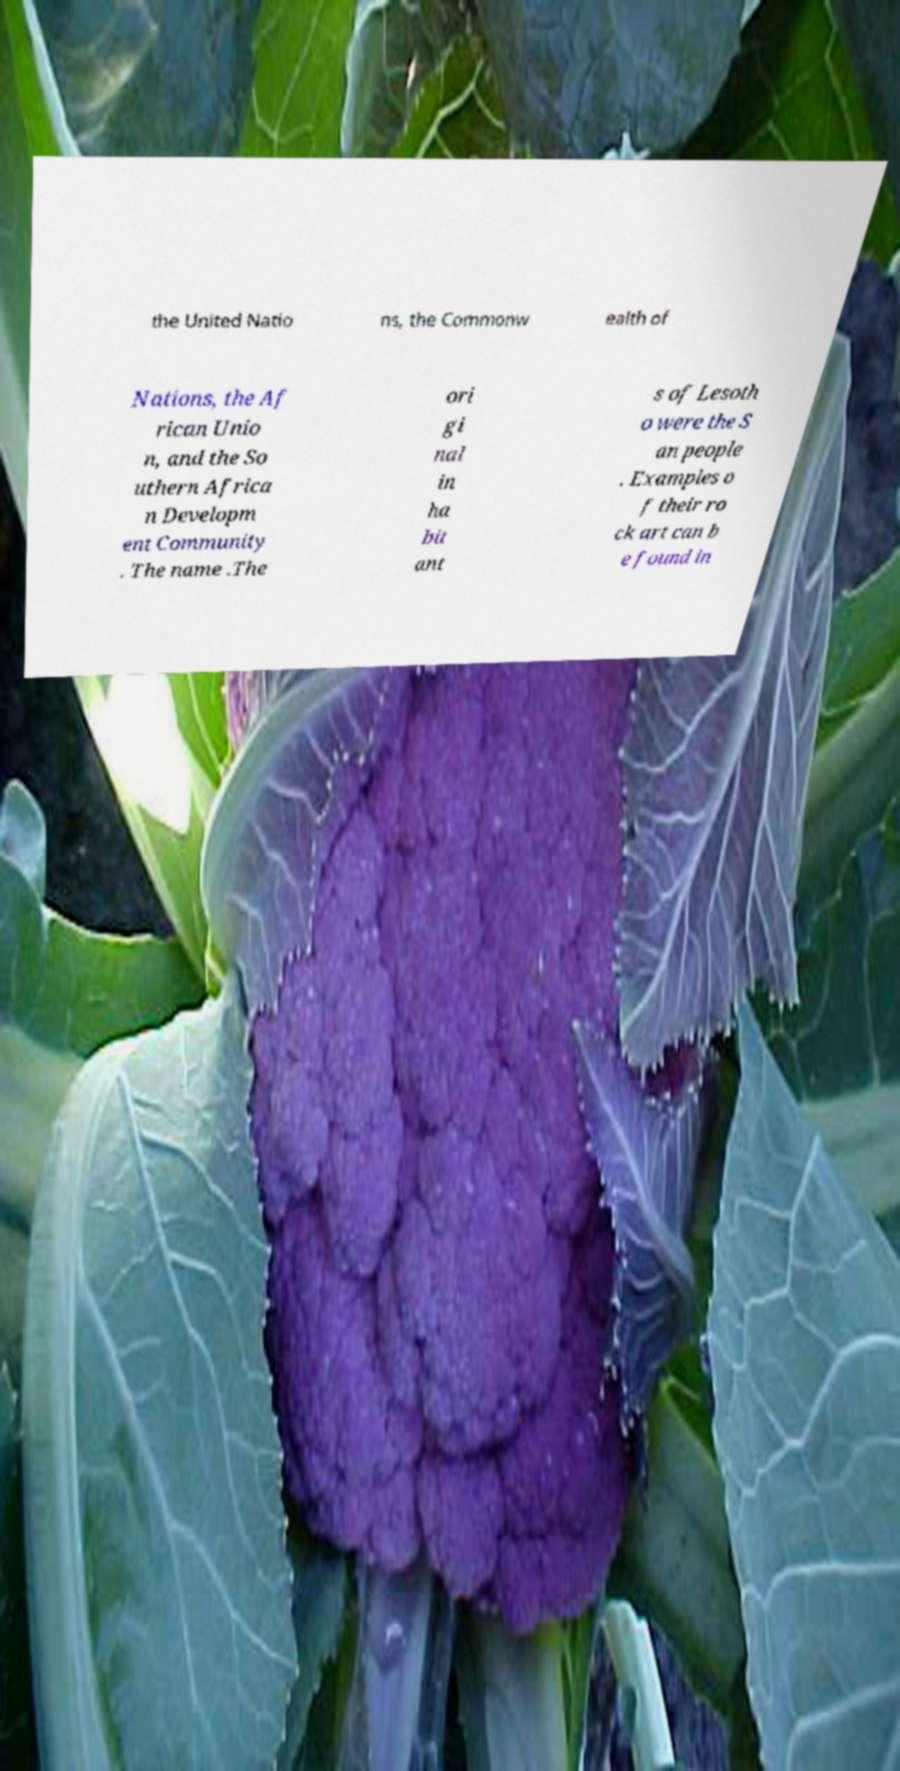There's text embedded in this image that I need extracted. Can you transcribe it verbatim? the United Natio ns, the Commonw ealth of Nations, the Af rican Unio n, and the So uthern Africa n Developm ent Community . The name .The ori gi nal in ha bit ant s of Lesoth o were the S an people . Examples o f their ro ck art can b e found in 